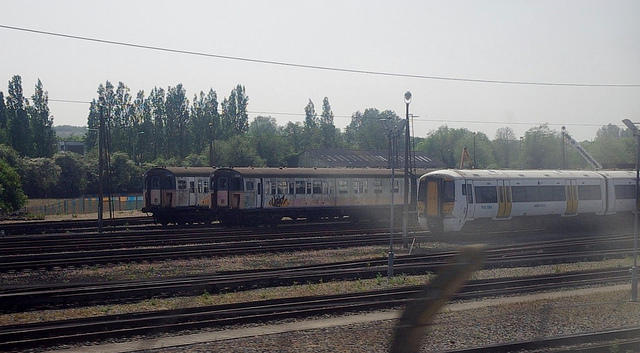<image>How are theses trains being powered? It is unknown how these trains are being powered. They could possibly be powered by electricity or diesel. How are theses trains being powered? I don't know how these trains are being powered. It can be either powered by electricity or diesel. 